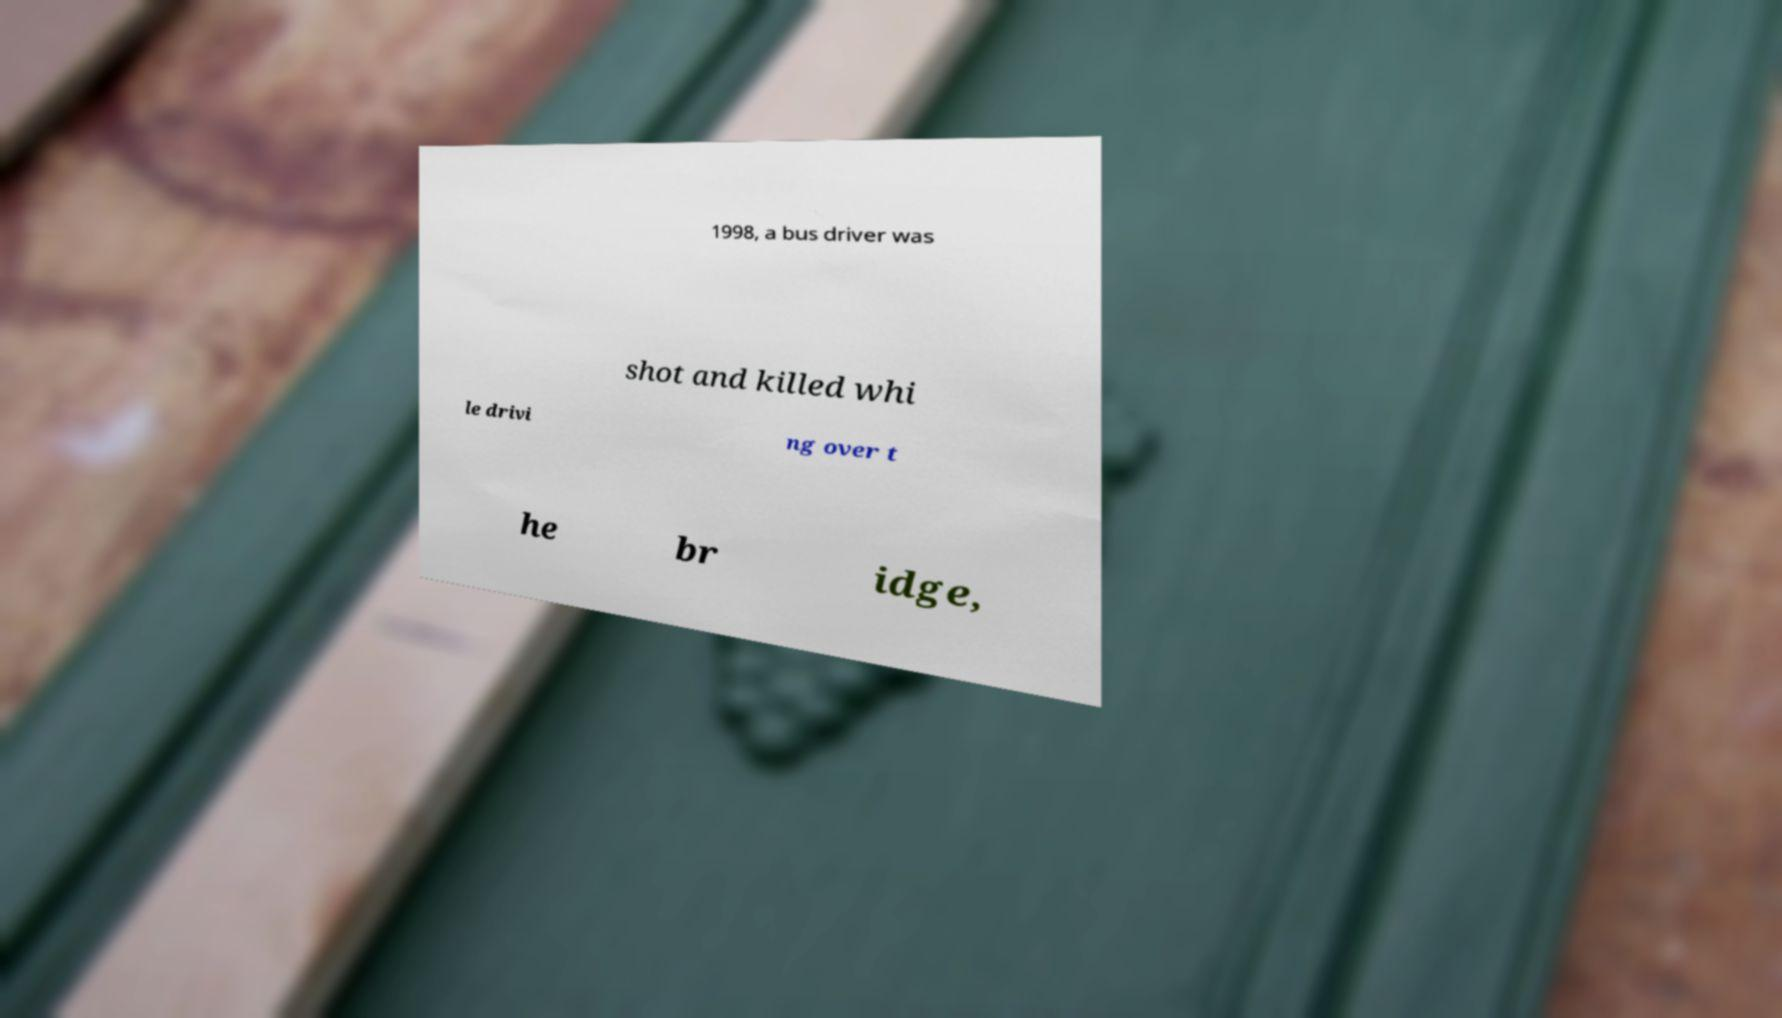What messages or text are displayed in this image? I need them in a readable, typed format. 1998, a bus driver was shot and killed whi le drivi ng over t he br idge, 